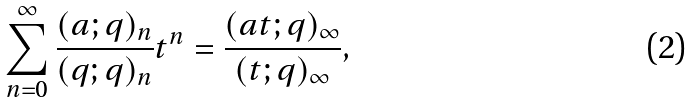Convert formula to latex. <formula><loc_0><loc_0><loc_500><loc_500>\sum _ { n = 0 } ^ { \infty } \frac { ( a ; q ) _ { n } } { ( q ; q ) _ { n } } t ^ { n } = \frac { ( a t ; q ) _ { \infty } } { ( t ; q ) _ { \infty } } ,</formula> 